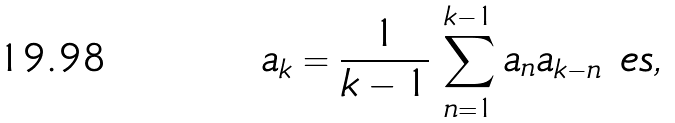<formula> <loc_0><loc_0><loc_500><loc_500>a _ { k } = \frac { 1 } { k - 1 } \, \sum _ { n = 1 } ^ { k - 1 } a _ { n } a _ { k - n } \ e s ,</formula> 